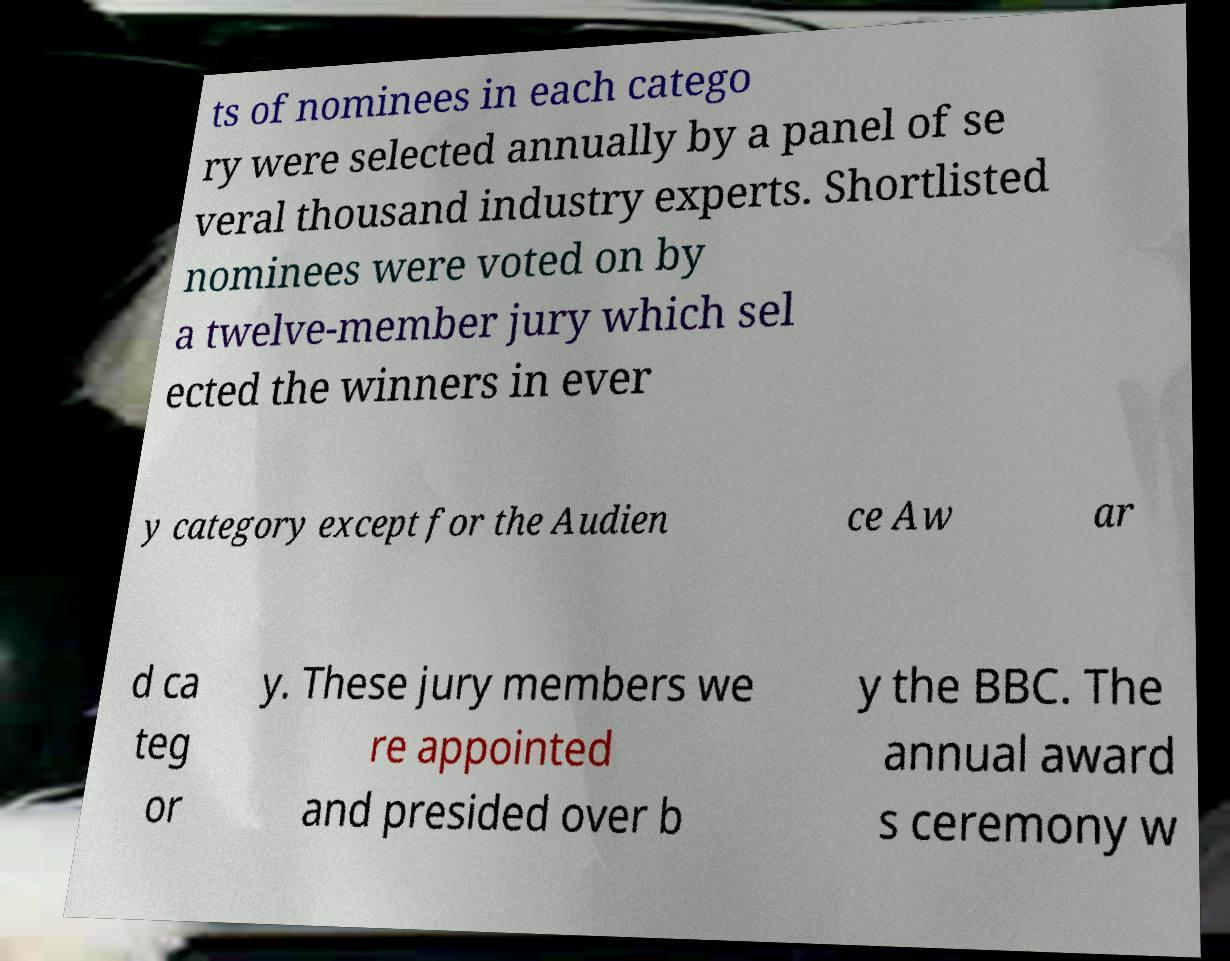Could you extract and type out the text from this image? ts of nominees in each catego ry were selected annually by a panel of se veral thousand industry experts. Shortlisted nominees were voted on by a twelve-member jury which sel ected the winners in ever y category except for the Audien ce Aw ar d ca teg or y. These jury members we re appointed and presided over b y the BBC. The annual award s ceremony w 